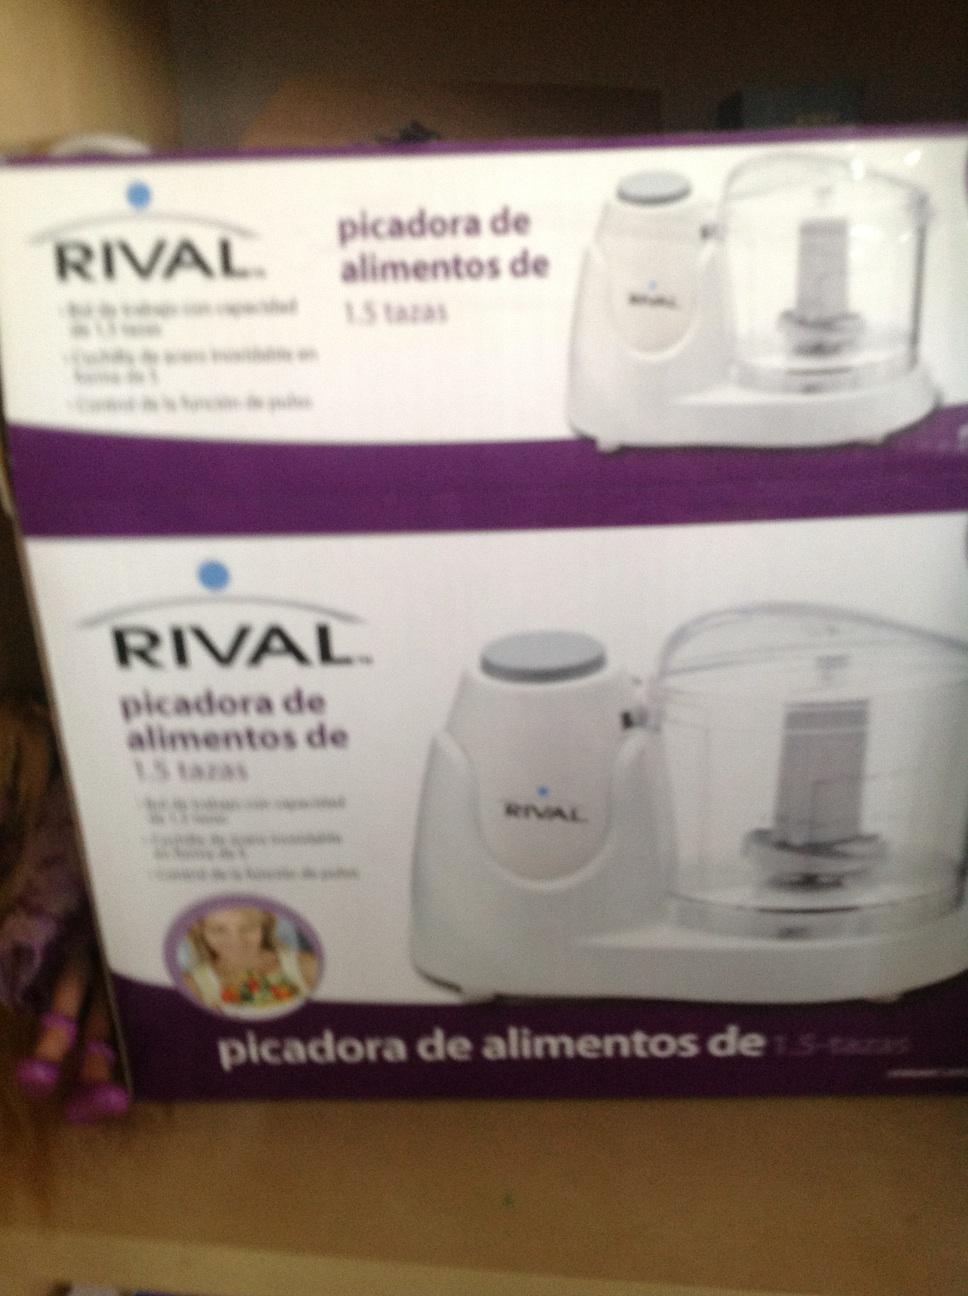Can you provide a short, creative scenario involving this food chopper? A busy working parent comes home late and needs to prepare dinner quickly. Using the RIVAL food chopper, they chop vegetables for a fresh salad and garlic for a quick pasta sauce in minutes. Despite the rush, the meal turns out delicious, bringing smiles and compliments from the family. 